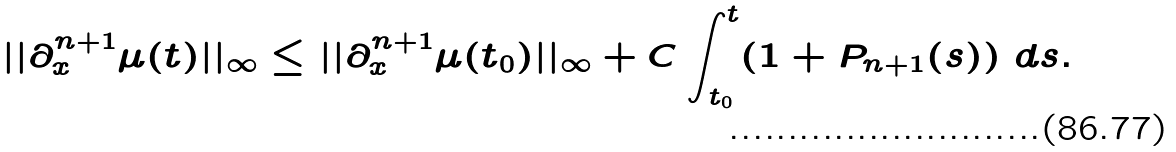Convert formula to latex. <formula><loc_0><loc_0><loc_500><loc_500>| | \partial _ { x } ^ { n + 1 } \mu ( t ) | | _ { \infty } \leq | | \partial _ { x } ^ { n + 1 } \mu ( t _ { 0 } ) | | _ { \infty } + C \int _ { t _ { 0 } } ^ { t } ( 1 + P _ { n + 1 } ( s ) ) \ d s .</formula> 